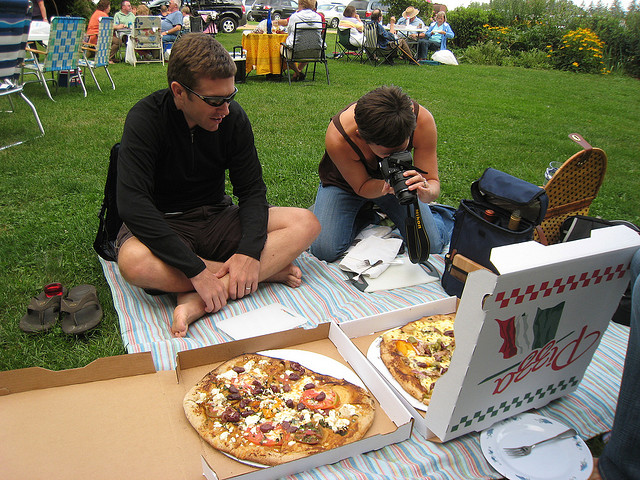<image>Is the pizza good? It is ambiguous whether the pizza tastes good or not as taste is subjective and differs from person to person. Is the pizza good? I don't know if the pizza is good. It can be good or not. 